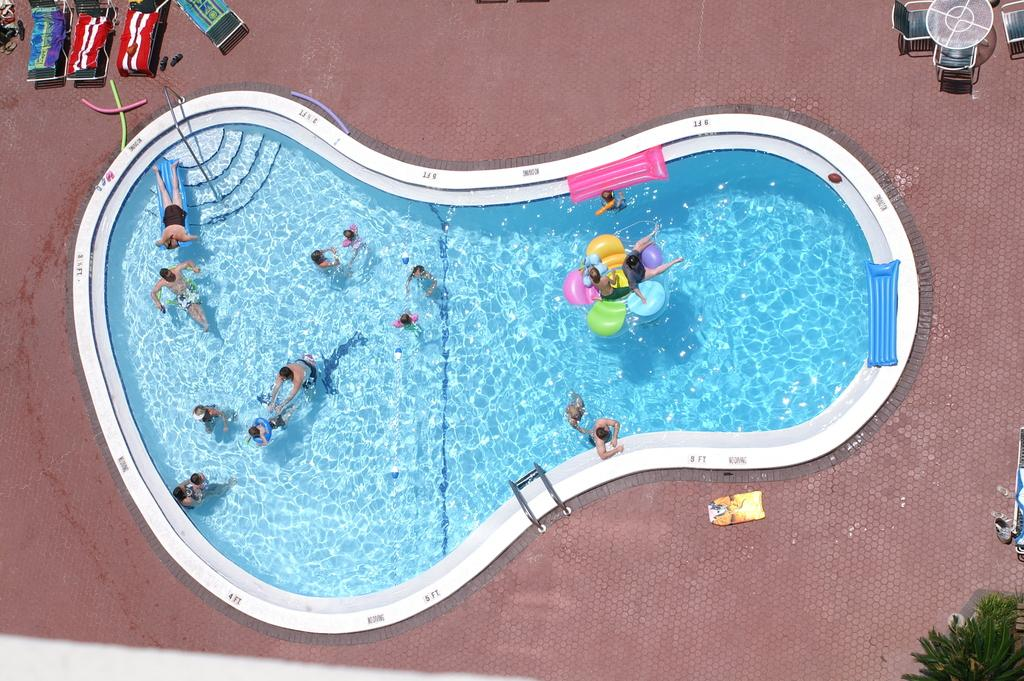What is the main subject of the image? The main subject of the image is a swimming pool from a top view. What color is the water in the pool? The water in the pool is blue. What are the people in the image doing? The people in the image are playing inside the swimming pool. Can you tell me where the church is located in the image? There is no church present in the image; it features a swimming pool. 